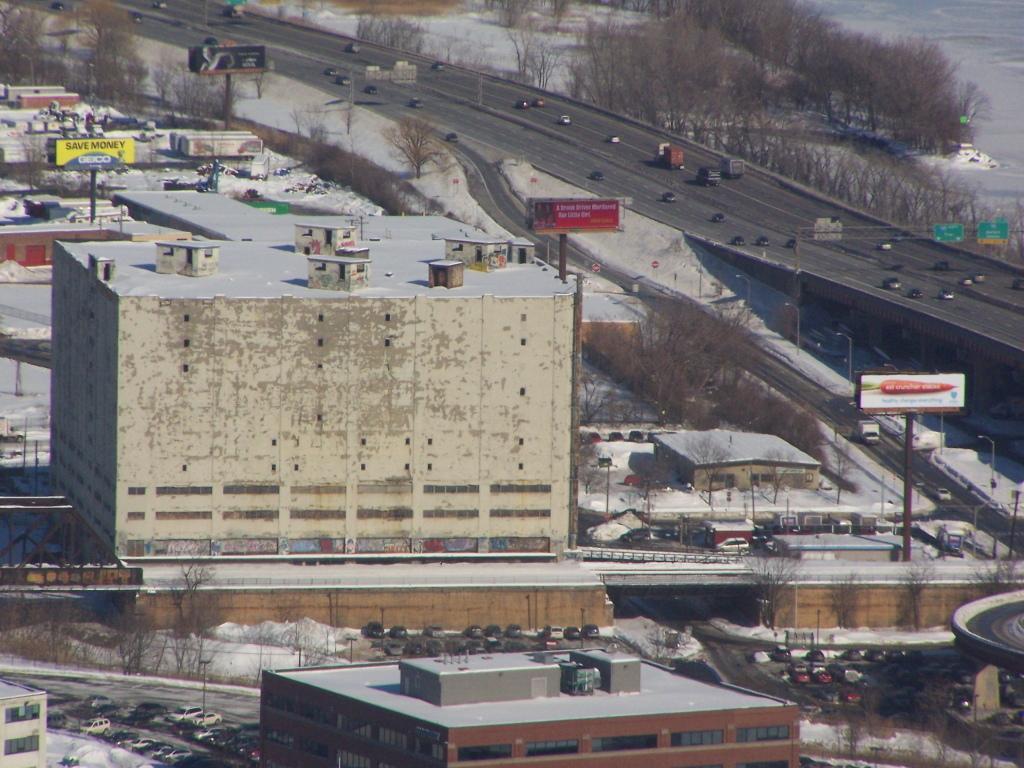In one or two sentences, can you explain what this image depicts? In this picture we can see buildings, trees, street lights and there are poles with the hoardings. There are vehicles on the roads. On the right side of the image, it looks like a truss and to the truss there are boards. 